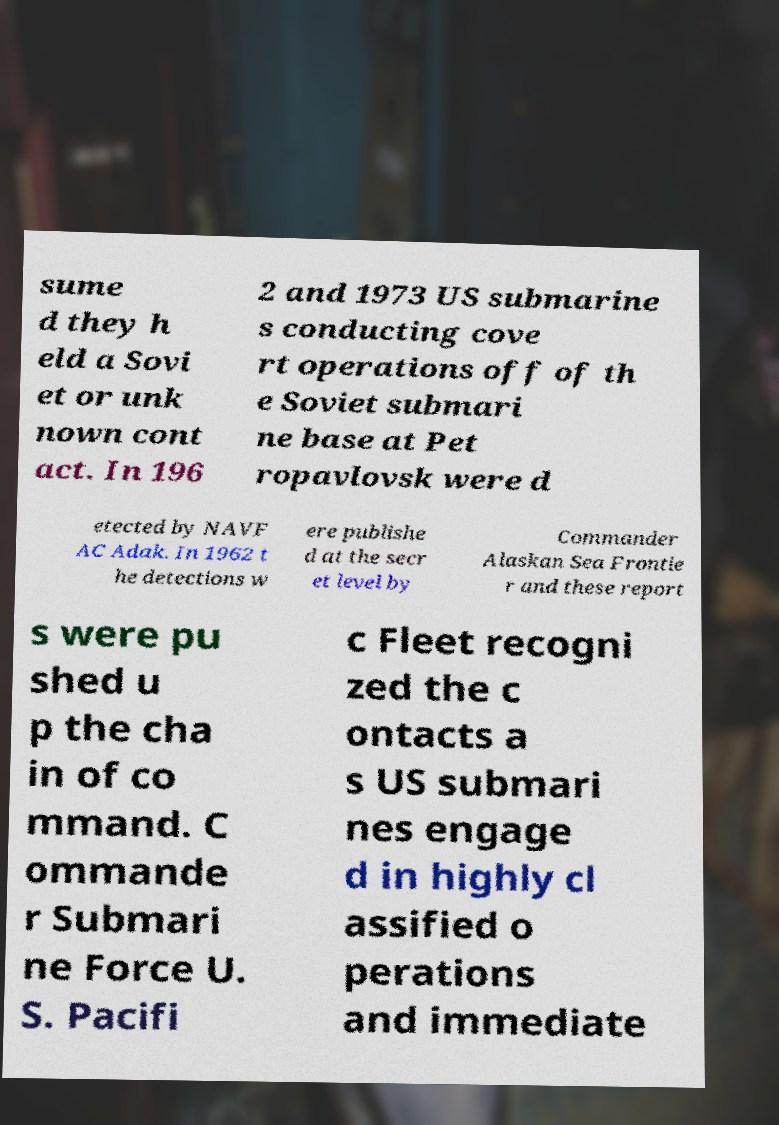What messages or text are displayed in this image? I need them in a readable, typed format. sume d they h eld a Sovi et or unk nown cont act. In 196 2 and 1973 US submarine s conducting cove rt operations off of th e Soviet submari ne base at Pet ropavlovsk were d etected by NAVF AC Adak. In 1962 t he detections w ere publishe d at the secr et level by Commander Alaskan Sea Frontie r and these report s were pu shed u p the cha in of co mmand. C ommande r Submari ne Force U. S. Pacifi c Fleet recogni zed the c ontacts a s US submari nes engage d in highly cl assified o perations and immediate 